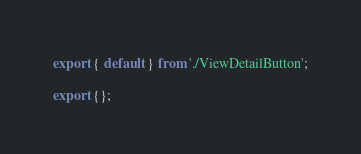<code> <loc_0><loc_0><loc_500><loc_500><_JavaScript_>export { default } from './ViewDetailButton';

export {};
</code> 